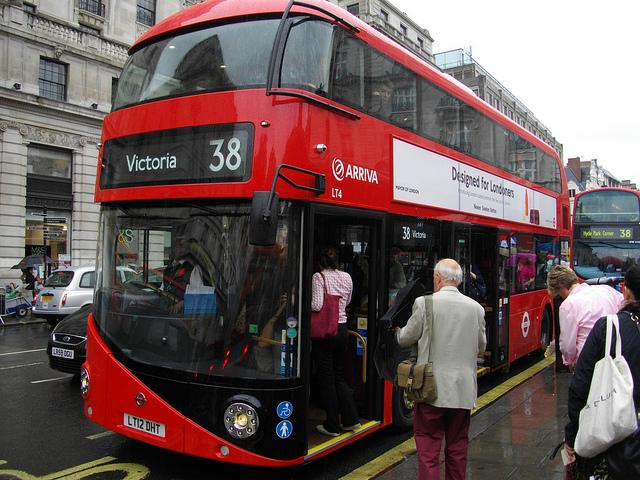What are these people waiting to do?

Choices:
A) board bus
B) see show
C) shop sale
D) get treatment board bus 